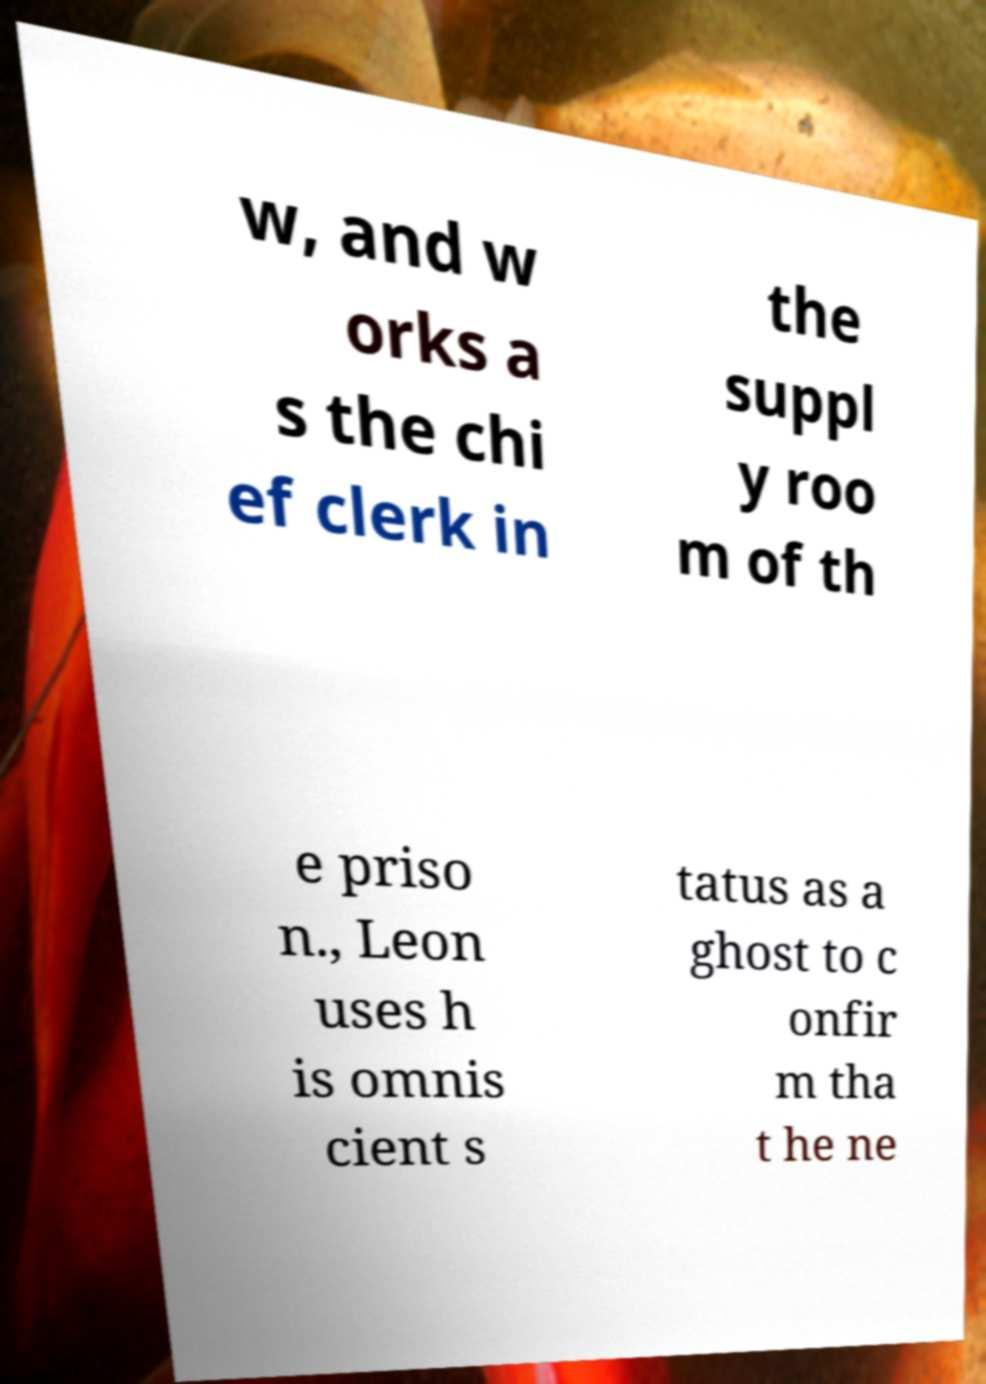Could you assist in decoding the text presented in this image and type it out clearly? w, and w orks a s the chi ef clerk in the suppl y roo m of th e priso n., Leon uses h is omnis cient s tatus as a ghost to c onfir m tha t he ne 